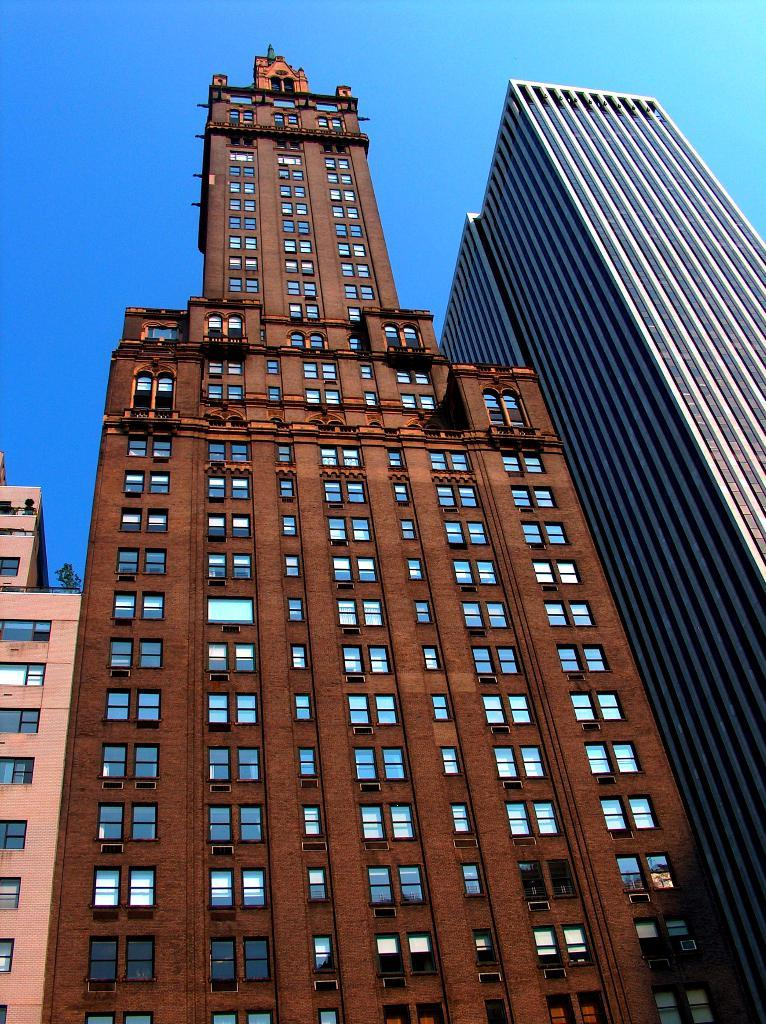What type of structures are present in the image? There are buildings in the image. What feature do the buildings have in common? The buildings have windows. What colors can be seen on the buildings in the image? The buildings are blue, brown, and pink in color. What can be seen in the background of the image? There is a sky visible in the background of the image. What type of instrument is being played in the image? There is no instrument present in the image; it only features buildings with windows, in blue, brown, and pink colors, and a visible sky in the background. 